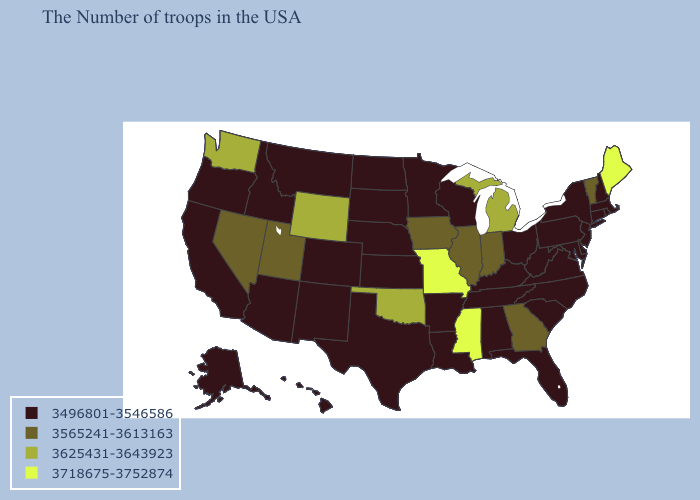What is the value of Wyoming?
Short answer required. 3625431-3643923. Name the states that have a value in the range 3718675-3752874?
Answer briefly. Maine, Mississippi, Missouri. What is the lowest value in the West?
Keep it brief. 3496801-3546586. Which states hav the highest value in the West?
Concise answer only. Wyoming, Washington. Among the states that border Illinois , does Missouri have the lowest value?
Keep it brief. No. Does Connecticut have the highest value in the Northeast?
Be succinct. No. What is the lowest value in the MidWest?
Short answer required. 3496801-3546586. What is the highest value in the USA?
Short answer required. 3718675-3752874. Does Missouri have the highest value in the USA?
Short answer required. Yes. What is the value of Oklahoma?
Quick response, please. 3625431-3643923. What is the value of Alaska?
Keep it brief. 3496801-3546586. Name the states that have a value in the range 3625431-3643923?
Be succinct. Michigan, Oklahoma, Wyoming, Washington. Name the states that have a value in the range 3565241-3613163?
Give a very brief answer. Vermont, Georgia, Indiana, Illinois, Iowa, Utah, Nevada. Name the states that have a value in the range 3496801-3546586?
Quick response, please. Massachusetts, Rhode Island, New Hampshire, Connecticut, New York, New Jersey, Delaware, Maryland, Pennsylvania, Virginia, North Carolina, South Carolina, West Virginia, Ohio, Florida, Kentucky, Alabama, Tennessee, Wisconsin, Louisiana, Arkansas, Minnesota, Kansas, Nebraska, Texas, South Dakota, North Dakota, Colorado, New Mexico, Montana, Arizona, Idaho, California, Oregon, Alaska, Hawaii. What is the value of Hawaii?
Answer briefly. 3496801-3546586. 